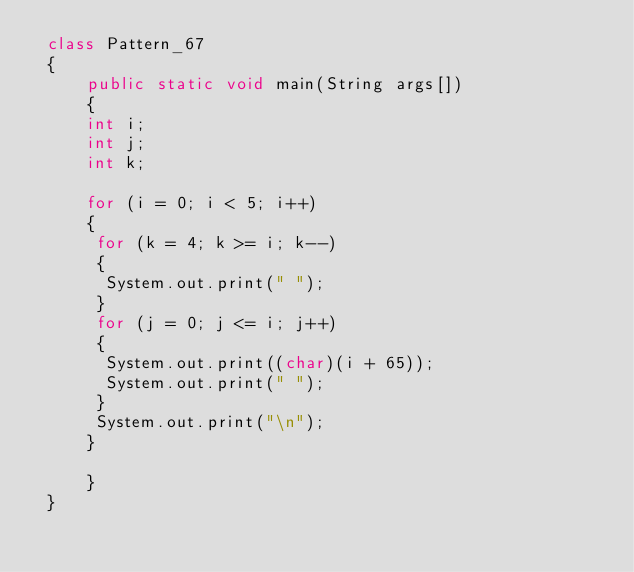<code> <loc_0><loc_0><loc_500><loc_500><_Java_> class Pattern_67
 {
     public static void main(String args[])
     {
     int i;
     int j;
     int k;
      
     for (i = 0; i < 5; i++)
     {
      for (k = 4; k >= i; k--)
      {
       System.out.print(" ");
      }
      for (j = 0; j <= i; j++)
      {
       System.out.print((char)(i + 65));
       System.out.print(" ");
      }
      System.out.print("\n");
     }
       
     }
 }</code> 